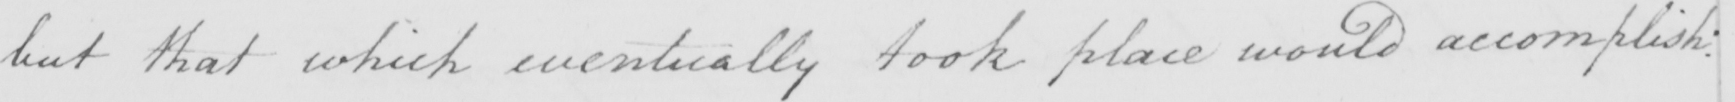Please transcribe the handwritten text in this image. but that which eventually took place would accomplish : 